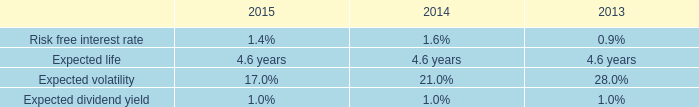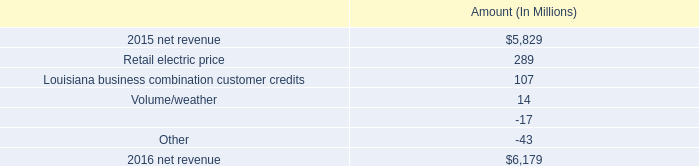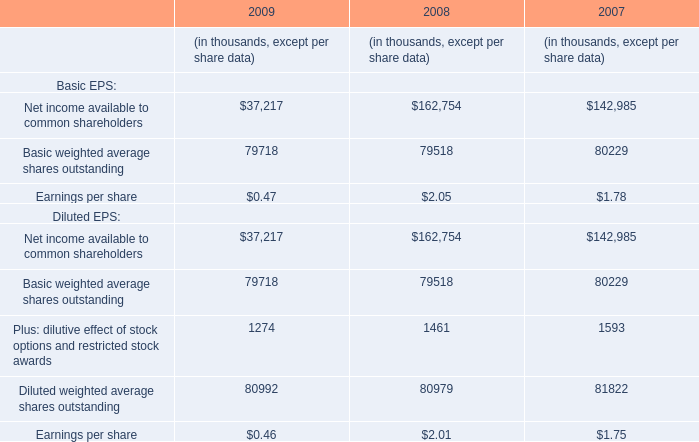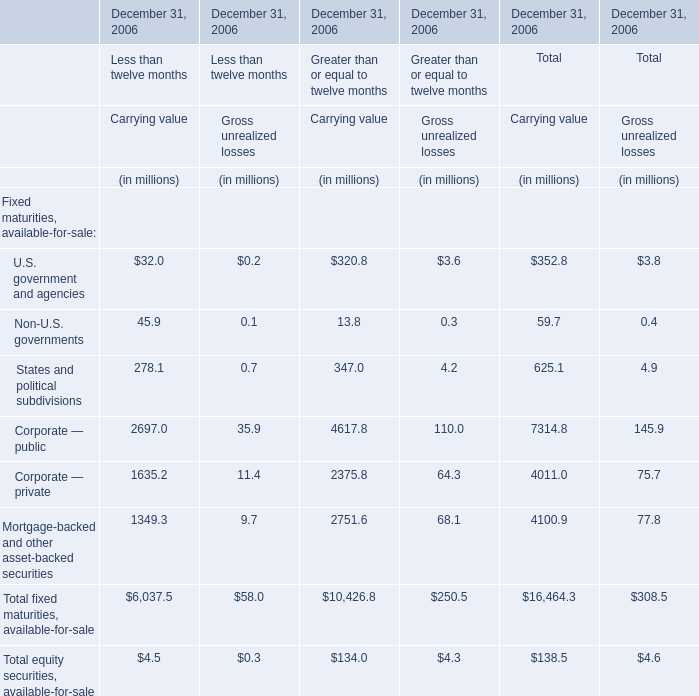Does the value of U.S. government and agencies inGross unrealized lossesgreater than that in Carrying value for Less than twelve months 
Answer: no. 